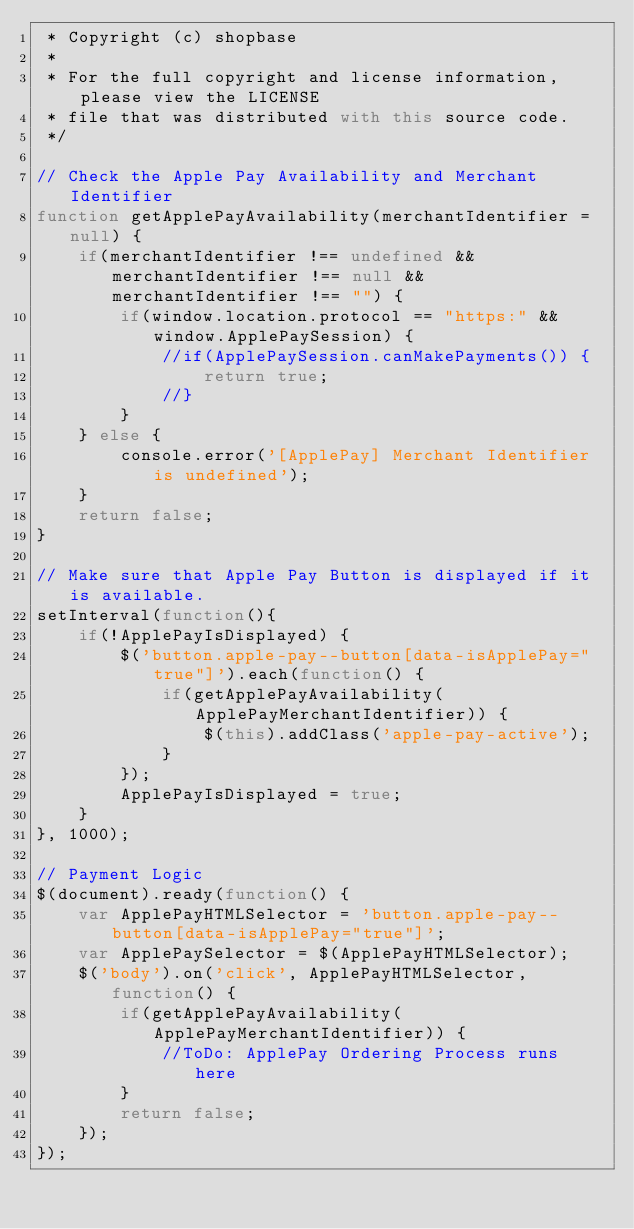Convert code to text. <code><loc_0><loc_0><loc_500><loc_500><_JavaScript_> * Copyright (c) shopbase
 *
 * For the full copyright and license information, please view the LICENSE
 * file that was distributed with this source code.
 */

// Check the Apple Pay Availability and Merchant Identifier
function getApplePayAvailability(merchantIdentifier = null) {
    if(merchantIdentifier !== undefined && merchantIdentifier !== null && merchantIdentifier !== "") {
        if(window.location.protocol == "https:" && window.ApplePaySession) {
            //if(ApplePaySession.canMakePayments()) {
                return true;
            //}
        }
    } else {
        console.error('[ApplePay] Merchant Identifier is undefined');
    }
    return false;
}

// Make sure that Apple Pay Button is displayed if it is available.
setInterval(function(){
    if(!ApplePayIsDisplayed) {
        $('button.apple-pay--button[data-isApplePay="true"]').each(function() {
            if(getApplePayAvailability(ApplePayMerchantIdentifier)) {
                $(this).addClass('apple-pay-active');
            }
        });
        ApplePayIsDisplayed = true;
    }
}, 1000);

// Payment Logic
$(document).ready(function() {
    var ApplePayHTMLSelector = 'button.apple-pay--button[data-isApplePay="true"]';
    var ApplePaySelector = $(ApplePayHTMLSelector);
    $('body').on('click', ApplePayHTMLSelector, function() {
        if(getApplePayAvailability(ApplePayMerchantIdentifier)) {
            //ToDo: ApplePay Ordering Process runs here
        }
        return false;
    });
});</code> 